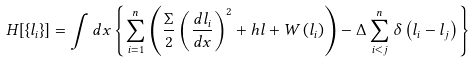<formula> <loc_0><loc_0><loc_500><loc_500>H [ \{ l _ { i } \} ] = \int d x \left \{ \sum _ { i = 1 } ^ { n } \left ( \frac { \Sigma } { 2 } \left ( \frac { d l _ { i } } { d x } \right ) ^ { 2 } + h l + W \left ( l _ { i } \right ) \right ) - \Delta \sum _ { i < j } ^ { n } \delta \left ( l _ { i } - l _ { j } \right ) \right \}</formula> 